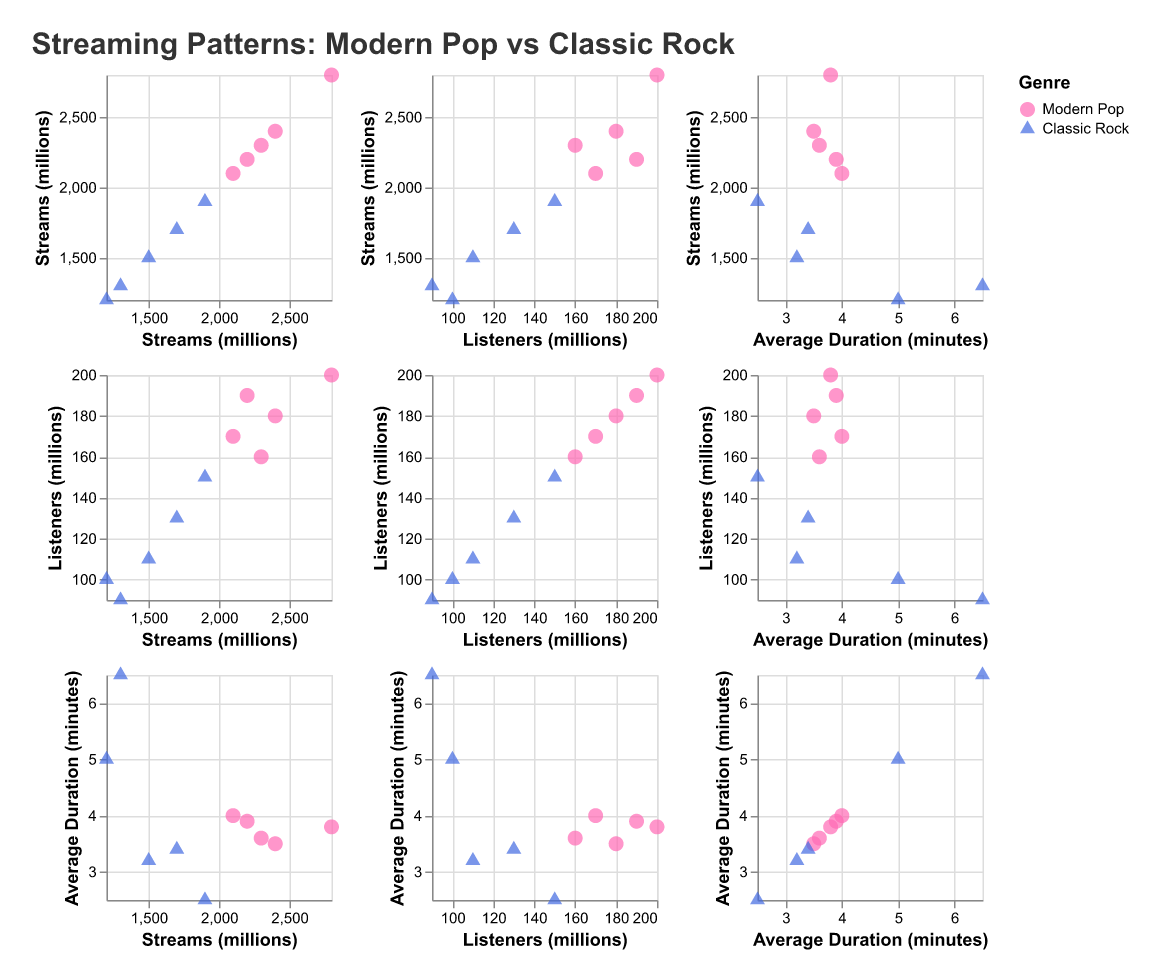What is the genre with the highest number of streams? First, identify the data points for both genres. The highest number of streams belongs to Ed Sheeran (Modern Pop) with 2800 million streams, which is higher than any Classic Rock artist.
Answer: Modern Pop Which artist has the longest average song duration? Look at the 'Average Duration (minutes)' column. Pink Floyd has the highest average song duration of 6.5 minutes.
Answer: Pink Floyd How many artists in the Classic Rock genre are from the UK? Count the number of data points in the Classic Rock genre where "Top Country" is "UK". The Beatles and Queen are the two artists, so the number is 2.
Answer: 2 What is the average duration of songs for Modern Pop artists? Add the average durations for Modern Pop artists (3.5 + 4.0 + 3.8 + 3.6 + 3.9) and divide by the number of artists (5). This equals (18.8/5) = 3.76 minutes.
Answer: 3.76 minutes Which genre generally has longer average song durations? Compare the average durations in both genres. Classic Rock has longer average durations based on the data points provided (most notably Pink Floyd with 6.5 minutes and Led Zeppelin with 5.0 minutes).
Answer: Classic Rock Is there a correlation between the number of streams and the number of listeners for Modern Pop artists? Observe the scatter plots where both axes are 'Streams (millions)' and 'Listeners (millions)'. Modern Pop artists show a positive correlation; those with more streams generally have more listeners.
Answer: Yes What is the relationship between the streams and average duration for Classic Rock artists? Analyze the scatter plot comparing 'Streams (millions)' and 'Average Duration (minutes)' for Classic Rock. There isn’t a clear linear relationship; examples include Led Zeppelin with a high average duration but relatively fewer streams.
Answer: No clear relationship Which artist has more listeners: Queen or Billie Eilish? Compare the data points for Queen and Billie Eilish in 'Listeners (millions)'. Billie Eilish has 170 million listeners, while Queen has 130 million.
Answer: Billie Eilish How do the number of streams for the top Modern Pop artist compare to the top Classic Rock artist? The top Modern Pop artist in terms of streams is Ed Sheeran with 2800 million streams. The top Classic Rock artist is The Beatles with 1900 million streams. Therefore, Ed Sheeran has more streams than The Beatles.
Answer: More What is the total number of streams for artists who are from the USA? Sum up streams of artists where "Top Country" is "USA". Modern Pop artists: Ariana Grande (2400), Billie Eilish (2100), Dua Lipa (2300), Post Malone (2200). Classic Rock artists: Led Zeppelin (1200), Rolling Stones (1500), Pink Floyd (1300). The total is 2400 + 2100 + 2300 + 2200 + 1200 + 1500 + 1300 = 13000 million streams.
Answer: 13000 million streams 